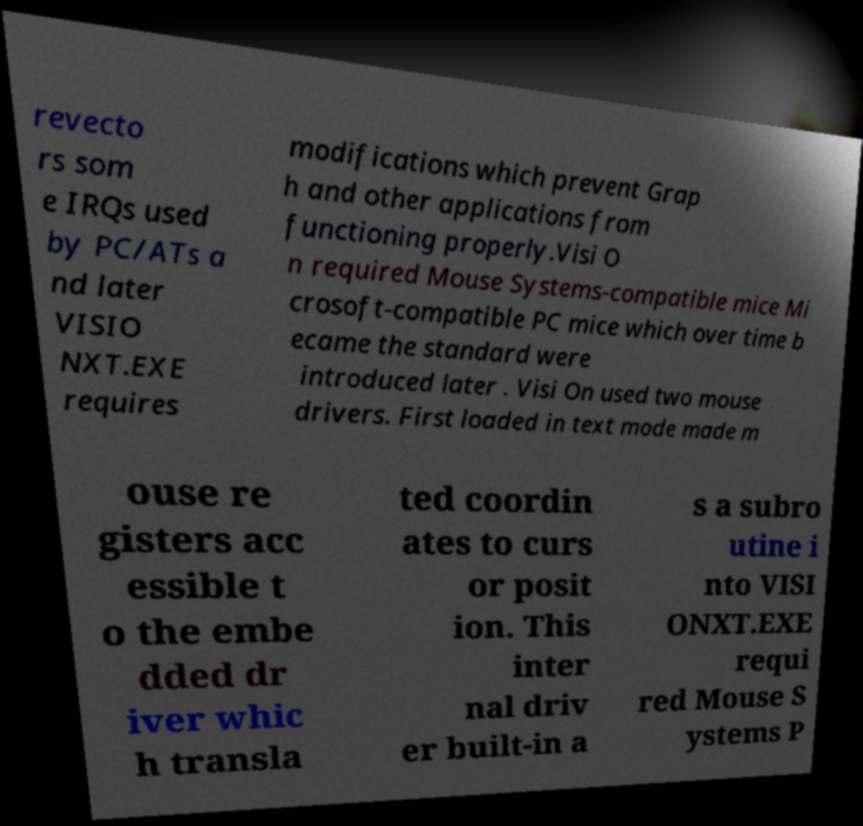Please identify and transcribe the text found in this image. revecto rs som e IRQs used by PC/ATs a nd later VISIO NXT.EXE requires modifications which prevent Grap h and other applications from functioning properly.Visi O n required Mouse Systems-compatible mice Mi crosoft-compatible PC mice which over time b ecame the standard were introduced later . Visi On used two mouse drivers. First loaded in text mode made m ouse re gisters acc essible t o the embe dded dr iver whic h transla ted coordin ates to curs or posit ion. This inter nal driv er built-in a s a subro utine i nto VISI ONXT.EXE requi red Mouse S ystems P 